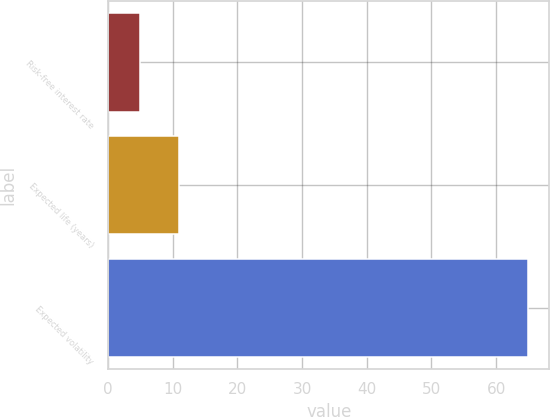Convert chart to OTSL. <chart><loc_0><loc_0><loc_500><loc_500><bar_chart><fcel>Risk-free interest rate<fcel>Expected life (years)<fcel>Expected volatility<nl><fcel>4.97<fcel>10.97<fcel>65<nl></chart> 